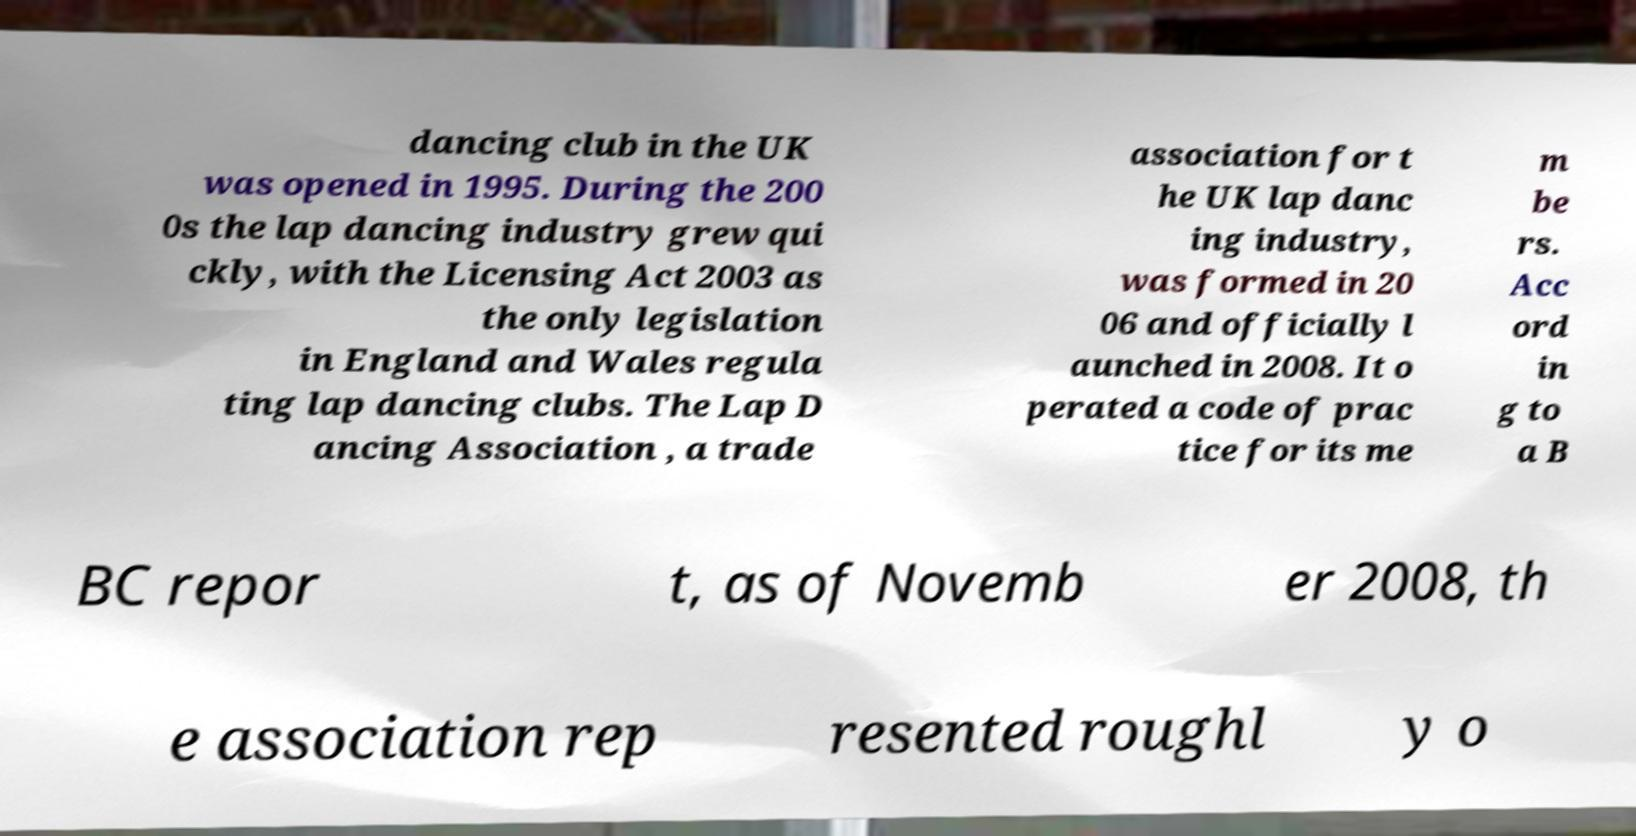What messages or text are displayed in this image? I need them in a readable, typed format. dancing club in the UK was opened in 1995. During the 200 0s the lap dancing industry grew qui ckly, with the Licensing Act 2003 as the only legislation in England and Wales regula ting lap dancing clubs. The Lap D ancing Association , a trade association for t he UK lap danc ing industry, was formed in 20 06 and officially l aunched in 2008. It o perated a code of prac tice for its me m be rs. Acc ord in g to a B BC repor t, as of Novemb er 2008, th e association rep resented roughl y o 